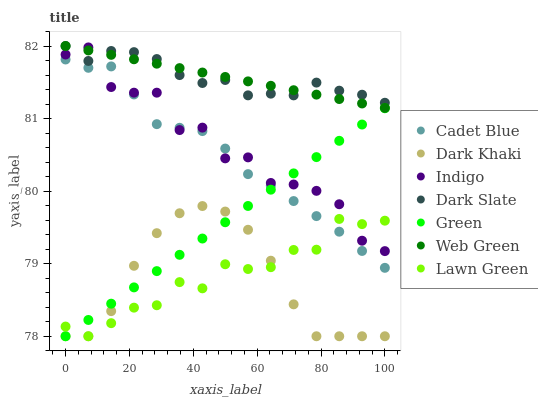Does Dark Khaki have the minimum area under the curve?
Answer yes or no. Yes. Does Web Green have the maximum area under the curve?
Answer yes or no. Yes. Does Cadet Blue have the minimum area under the curve?
Answer yes or no. No. Does Cadet Blue have the maximum area under the curve?
Answer yes or no. No. Is Green the smoothest?
Answer yes or no. Yes. Is Indigo the roughest?
Answer yes or no. Yes. Is Cadet Blue the smoothest?
Answer yes or no. No. Is Cadet Blue the roughest?
Answer yes or no. No. Does Lawn Green have the lowest value?
Answer yes or no. Yes. Does Cadet Blue have the lowest value?
Answer yes or no. No. Does Dark Slate have the highest value?
Answer yes or no. Yes. Does Cadet Blue have the highest value?
Answer yes or no. No. Is Dark Khaki less than Dark Slate?
Answer yes or no. Yes. Is Dark Slate greater than Dark Khaki?
Answer yes or no. Yes. Does Green intersect Lawn Green?
Answer yes or no. Yes. Is Green less than Lawn Green?
Answer yes or no. No. Is Green greater than Lawn Green?
Answer yes or no. No. Does Dark Khaki intersect Dark Slate?
Answer yes or no. No. 